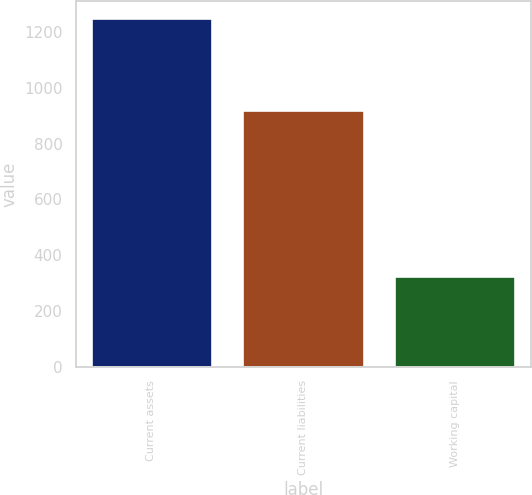<chart> <loc_0><loc_0><loc_500><loc_500><bar_chart><fcel>Current assets<fcel>Current liabilities<fcel>Working capital<nl><fcel>1247.8<fcel>921.8<fcel>326<nl></chart> 